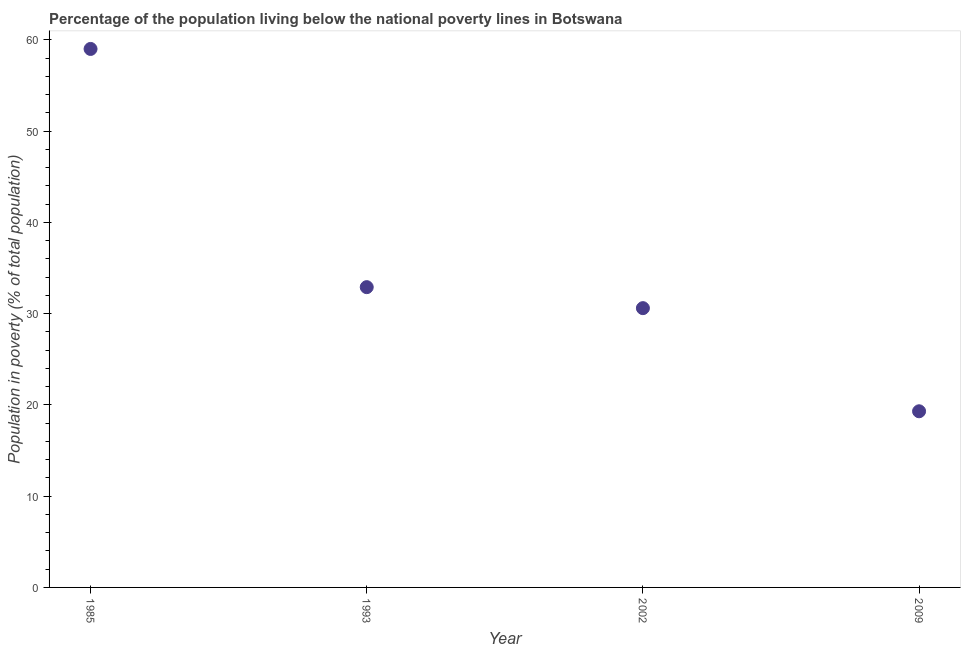What is the percentage of population living below poverty line in 2009?
Your answer should be compact. 19.3. Across all years, what is the maximum percentage of population living below poverty line?
Your response must be concise. 59. Across all years, what is the minimum percentage of population living below poverty line?
Make the answer very short. 19.3. In which year was the percentage of population living below poverty line maximum?
Keep it short and to the point. 1985. What is the sum of the percentage of population living below poverty line?
Your answer should be very brief. 141.8. What is the difference between the percentage of population living below poverty line in 1985 and 2002?
Give a very brief answer. 28.4. What is the average percentage of population living below poverty line per year?
Your response must be concise. 35.45. What is the median percentage of population living below poverty line?
Provide a short and direct response. 31.75. Do a majority of the years between 1993 and 2009 (inclusive) have percentage of population living below poverty line greater than 30 %?
Your answer should be compact. Yes. What is the ratio of the percentage of population living below poverty line in 1993 to that in 2002?
Offer a terse response. 1.08. Is the percentage of population living below poverty line in 1985 less than that in 2002?
Provide a succinct answer. No. Is the difference between the percentage of population living below poverty line in 1985 and 1993 greater than the difference between any two years?
Your response must be concise. No. What is the difference between the highest and the second highest percentage of population living below poverty line?
Your answer should be compact. 26.1. What is the difference between the highest and the lowest percentage of population living below poverty line?
Your response must be concise. 39.7. Does the percentage of population living below poverty line monotonically increase over the years?
Your answer should be compact. No. Does the graph contain any zero values?
Your answer should be very brief. No. Does the graph contain grids?
Provide a succinct answer. No. What is the title of the graph?
Ensure brevity in your answer.  Percentage of the population living below the national poverty lines in Botswana. What is the label or title of the Y-axis?
Your response must be concise. Population in poverty (% of total population). What is the Population in poverty (% of total population) in 1985?
Give a very brief answer. 59. What is the Population in poverty (% of total population) in 1993?
Your answer should be very brief. 32.9. What is the Population in poverty (% of total population) in 2002?
Offer a terse response. 30.6. What is the Population in poverty (% of total population) in 2009?
Offer a terse response. 19.3. What is the difference between the Population in poverty (% of total population) in 1985 and 1993?
Your response must be concise. 26.1. What is the difference between the Population in poverty (% of total population) in 1985 and 2002?
Give a very brief answer. 28.4. What is the difference between the Population in poverty (% of total population) in 1985 and 2009?
Your answer should be very brief. 39.7. What is the difference between the Population in poverty (% of total population) in 1993 and 2002?
Offer a very short reply. 2.3. What is the difference between the Population in poverty (% of total population) in 2002 and 2009?
Offer a very short reply. 11.3. What is the ratio of the Population in poverty (% of total population) in 1985 to that in 1993?
Give a very brief answer. 1.79. What is the ratio of the Population in poverty (% of total population) in 1985 to that in 2002?
Your answer should be very brief. 1.93. What is the ratio of the Population in poverty (% of total population) in 1985 to that in 2009?
Offer a terse response. 3.06. What is the ratio of the Population in poverty (% of total population) in 1993 to that in 2002?
Make the answer very short. 1.07. What is the ratio of the Population in poverty (% of total population) in 1993 to that in 2009?
Make the answer very short. 1.71. What is the ratio of the Population in poverty (% of total population) in 2002 to that in 2009?
Make the answer very short. 1.58. 